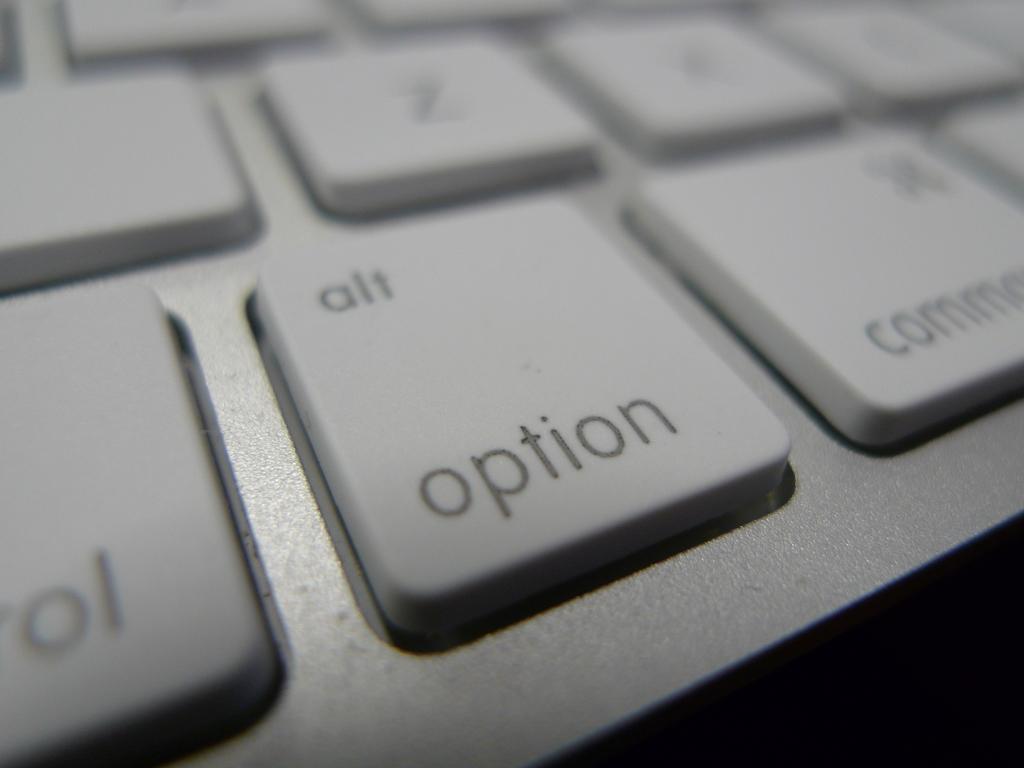What else is written on the alt button?
Your answer should be very brief. Option. 